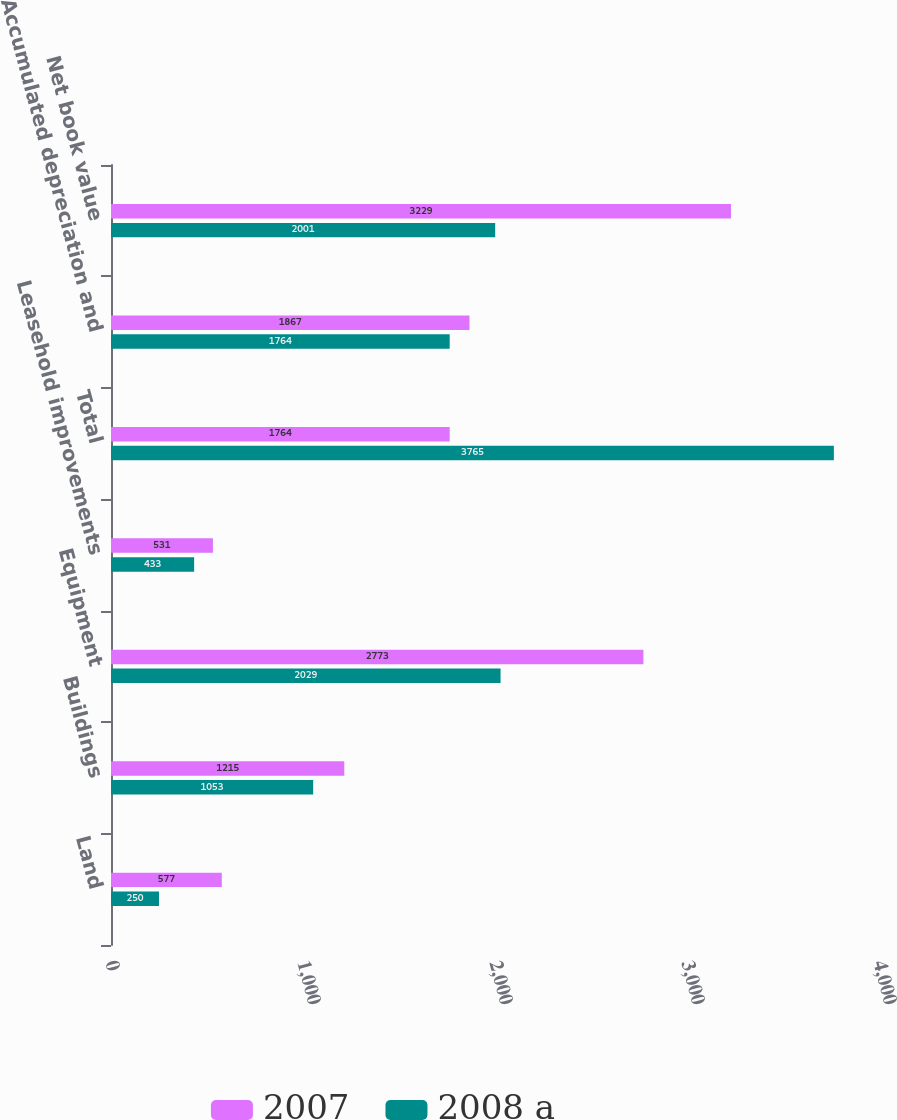<chart> <loc_0><loc_0><loc_500><loc_500><stacked_bar_chart><ecel><fcel>Land<fcel>Buildings<fcel>Equipment<fcel>Leasehold improvements<fcel>Total<fcel>Accumulated depreciation and<fcel>Net book value<nl><fcel>2007<fcel>577<fcel>1215<fcel>2773<fcel>531<fcel>1764<fcel>1867<fcel>3229<nl><fcel>2008 a<fcel>250<fcel>1053<fcel>2029<fcel>433<fcel>3765<fcel>1764<fcel>2001<nl></chart> 